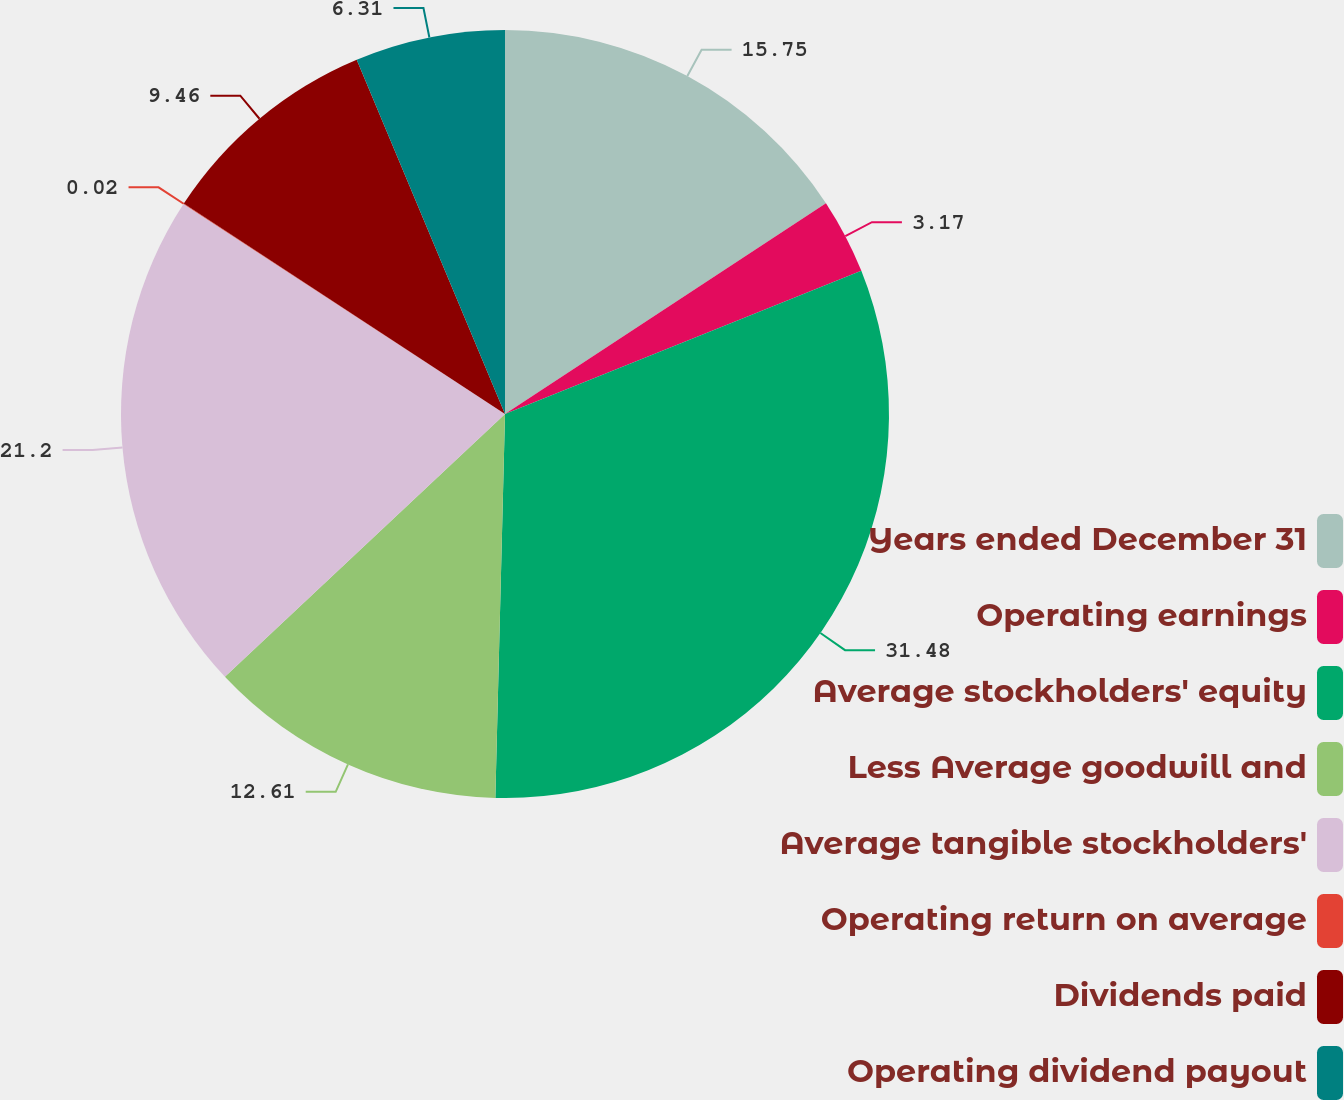Convert chart. <chart><loc_0><loc_0><loc_500><loc_500><pie_chart><fcel>Years ended December 31<fcel>Operating earnings<fcel>Average stockholders' equity<fcel>Less Average goodwill and<fcel>Average tangible stockholders'<fcel>Operating return on average<fcel>Dividends paid<fcel>Operating dividend payout<nl><fcel>15.75%<fcel>3.17%<fcel>31.48%<fcel>12.61%<fcel>21.2%<fcel>0.02%<fcel>9.46%<fcel>6.31%<nl></chart> 